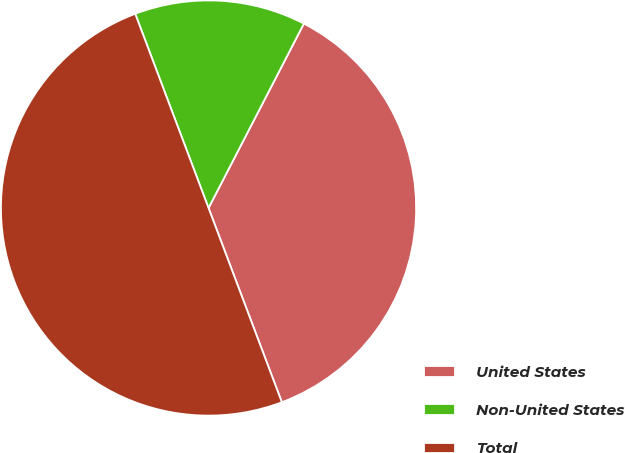Convert chart. <chart><loc_0><loc_0><loc_500><loc_500><pie_chart><fcel>United States<fcel>Non-United States<fcel>Total<nl><fcel>36.66%<fcel>13.34%<fcel>50.0%<nl></chart> 